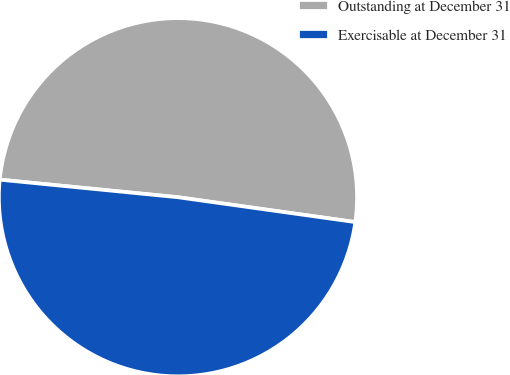Convert chart to OTSL. <chart><loc_0><loc_0><loc_500><loc_500><pie_chart><fcel>Outstanding at December 31<fcel>Exercisable at December 31<nl><fcel>50.65%<fcel>49.35%<nl></chart> 